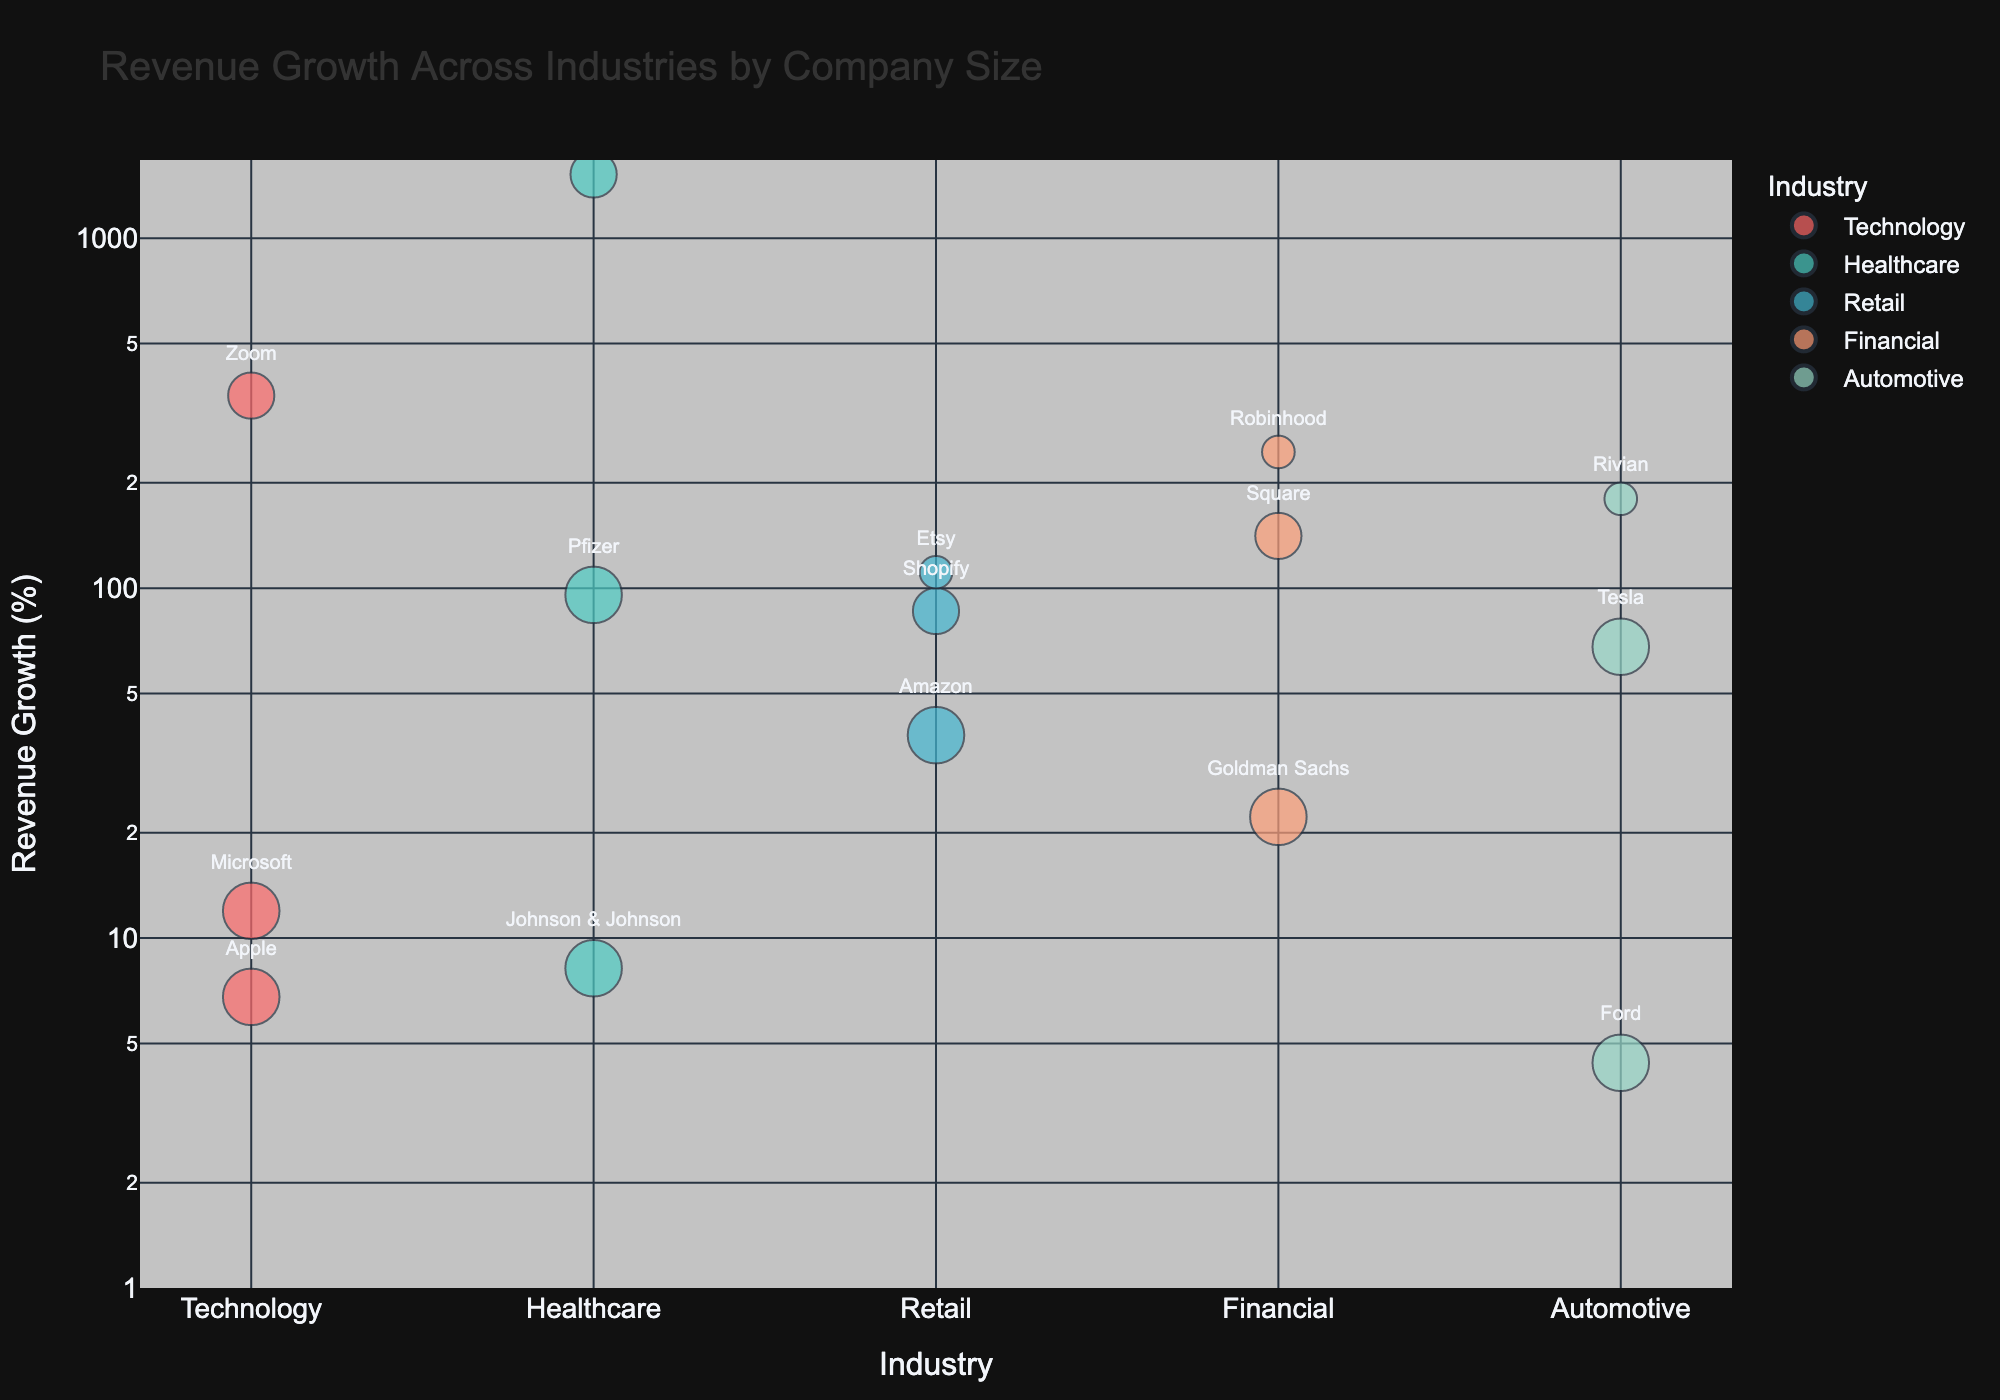What's the title of the bubble chart? The title of the bubble chart is located at the top, usually centered. The text specifies the subject of the visual representation. It is "Revenue Growth Across Industries by Company Size" in this case.
Answer: Revenue Growth Across Industries by Company Size How many bubbles represent companies in the Healthcare industry? To determine the number of bubbles representing companies within an industry, locate the unique instances of the industry in question. From the figure, this involves counting the bubbles associated with "Healthcare". There are three: Johnson & Johnson, Moderna, and Pfizer.
Answer: 3 Which company in the Technology industry has the highest revenue growth percentage? By identifying the Technology industry bubbles and comparing their y-axis values, which represent revenue growth percentages, we find that Zoom has the largest bubble size and the highest growth rate within this industry.
Answer: Zoom Between Amazon and Pfizer, which company has a higher revenue growth percentage and by how much? Locate Amazon and Pfizer on the y-axis to find their revenue growth percentages. Amazon is at 38%, and Pfizer is at 95.65%. Subtract Amazon's value from Pfizer's to determine the difference. 95.65% - 38% equals 57.65%.
Answer: Pfizer by 57.65% What is the general trend in revenue growth by company size within each industry? Observing the bubble sizes (which represent company sizes) and their positions along the y-axis (revenue growth), there is a noticeable trend where smaller companies tend to have higher revenue growth compared to larger companies within the same industry, as exemplified by figures like Zoom, Moderna, and Etsy.
Answer: Smaller companies generally have higher revenue growth Which industry has the most bubbles on the chart? By counting the number of bubbles within each industry group, we see that Technology has three bubbles (Apple, Microsoft, Zoom), Retail has three (Amazon, Shopify, Etsy), Healthcare has three (Johnson & Johnson, Moderna, Pfizer), Financial has three (Goldman Sachs, Square, Robinhood), and Automotive has three (Tesla, Rivian, Ford). Therefore, all industries have the same number of bubbles.
Answer: All industries have 3 bubbles What is the smallest company in the Automotive industry with the highest revenue growth? By identifying small-sized companies in the Automotive industry and comparing their revenue growth percentages, we find that Rivian is the small-sized company with the highest revenue growth at 180%.
Answer: Rivian How does the revenue growth of large companies compare across industries? By examining the bubbles sized for large companies (60) across different industries, we can compare their y-axis values. Apple (6.79%), Microsoft (11.96%), Johnson & Johnson (8.2%), Pfizer (95.65%), Amazon (38%), Goldman Sachs (22.2%), Tesla (68%), and Ford (4.4%) show that there's a diverse range of revenue growth among large companies across various industries.
Answer: Diverse range of growth What is the range of revenue growth percentages represented on the chart? By examining the y-axis scale of the bubble chart, we see the smallest revenue growth value from Ford at 4.4% and the largest from Moderna at 1521%. To calculate the range, we subtract the smallest value from the largest: 1521% - 4.4% = 1516.6%.
Answer: 1516.6% Which medium-sized company shows the highest revenue growth across all industries? Locate the medium-sized bubbles (size 40) and compare their positions on the y-axis representing revenue growth. Moderna from Healthcare shows the highest revenue growth at 1521%.
Answer: Moderna 